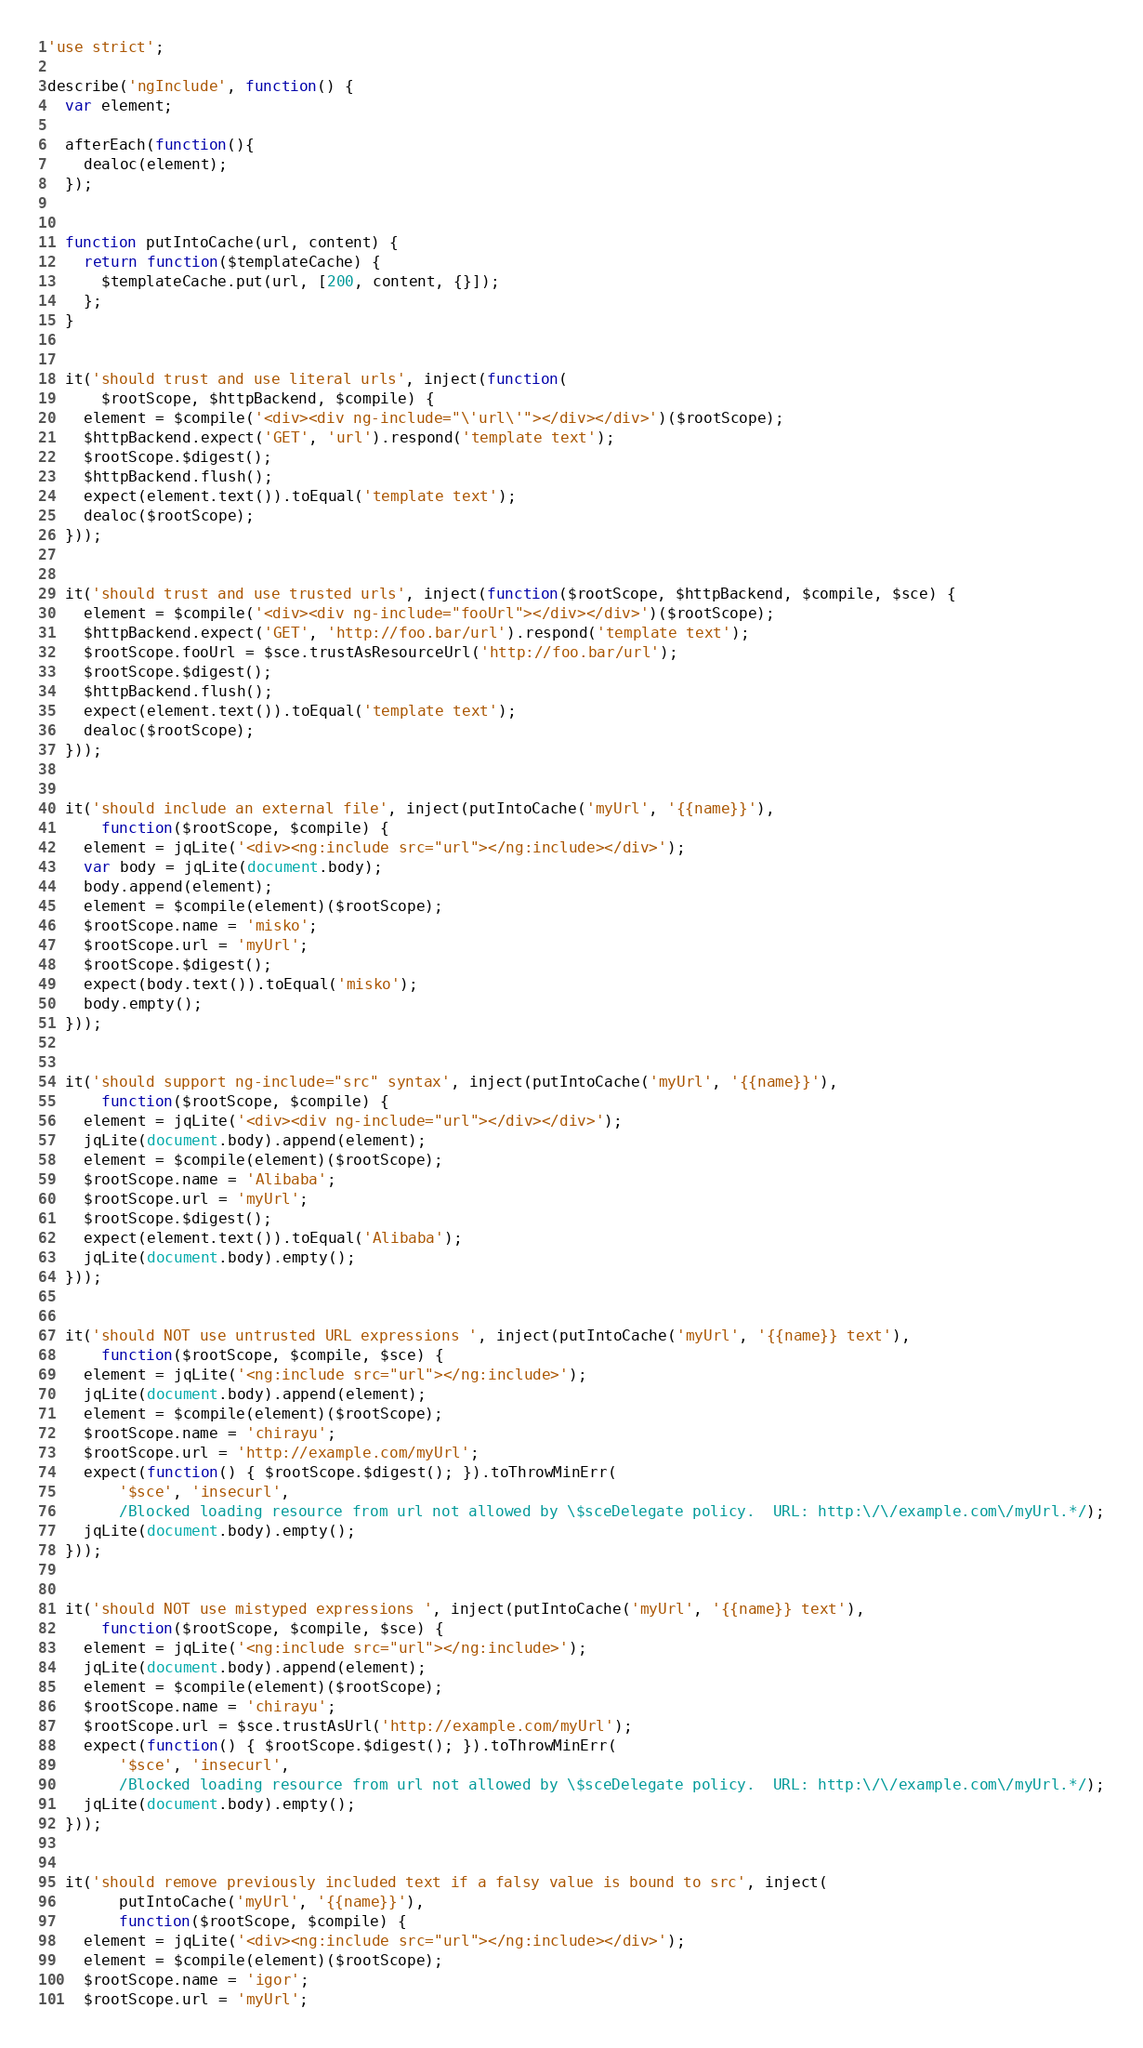Convert code to text. <code><loc_0><loc_0><loc_500><loc_500><_JavaScript_>'use strict';

describe('ngInclude', function() {
  var element;

  afterEach(function(){
    dealoc(element);
  });


  function putIntoCache(url, content) {
    return function($templateCache) {
      $templateCache.put(url, [200, content, {}]);
    };
  }


  it('should trust and use literal urls', inject(function(
      $rootScope, $httpBackend, $compile) {
    element = $compile('<div><div ng-include="\'url\'"></div></div>')($rootScope);
    $httpBackend.expect('GET', 'url').respond('template text');
    $rootScope.$digest();
    $httpBackend.flush();
    expect(element.text()).toEqual('template text');
    dealoc($rootScope);
  }));


  it('should trust and use trusted urls', inject(function($rootScope, $httpBackend, $compile, $sce) {
    element = $compile('<div><div ng-include="fooUrl"></div></div>')($rootScope);
    $httpBackend.expect('GET', 'http://foo.bar/url').respond('template text');
    $rootScope.fooUrl = $sce.trustAsResourceUrl('http://foo.bar/url');
    $rootScope.$digest();
    $httpBackend.flush();
    expect(element.text()).toEqual('template text');
    dealoc($rootScope);
  }));


  it('should include an external file', inject(putIntoCache('myUrl', '{{name}}'),
      function($rootScope, $compile) {
    element = jqLite('<div><ng:include src="url"></ng:include></div>');
    var body = jqLite(document.body);
    body.append(element);
    element = $compile(element)($rootScope);
    $rootScope.name = 'misko';
    $rootScope.url = 'myUrl';
    $rootScope.$digest();
    expect(body.text()).toEqual('misko');
    body.empty();
  }));


  it('should support ng-include="src" syntax', inject(putIntoCache('myUrl', '{{name}}'),
      function($rootScope, $compile) {
    element = jqLite('<div><div ng-include="url"></div></div>');
    jqLite(document.body).append(element);
    element = $compile(element)($rootScope);
    $rootScope.name = 'Alibaba';
    $rootScope.url = 'myUrl';
    $rootScope.$digest();
    expect(element.text()).toEqual('Alibaba');
    jqLite(document.body).empty();
  }));


  it('should NOT use untrusted URL expressions ', inject(putIntoCache('myUrl', '{{name}} text'),
      function($rootScope, $compile, $sce) {
    element = jqLite('<ng:include src="url"></ng:include>');
    jqLite(document.body).append(element);
    element = $compile(element)($rootScope);
    $rootScope.name = 'chirayu';
    $rootScope.url = 'http://example.com/myUrl';
    expect(function() { $rootScope.$digest(); }).toThrowMinErr(
        '$sce', 'insecurl',
        /Blocked loading resource from url not allowed by \$sceDelegate policy.  URL: http:\/\/example.com\/myUrl.*/);
    jqLite(document.body).empty();
  }));


  it('should NOT use mistyped expressions ', inject(putIntoCache('myUrl', '{{name}} text'),
      function($rootScope, $compile, $sce) {
    element = jqLite('<ng:include src="url"></ng:include>');
    jqLite(document.body).append(element);
    element = $compile(element)($rootScope);
    $rootScope.name = 'chirayu';
    $rootScope.url = $sce.trustAsUrl('http://example.com/myUrl');
    expect(function() { $rootScope.$digest(); }).toThrowMinErr(
        '$sce', 'insecurl',
        /Blocked loading resource from url not allowed by \$sceDelegate policy.  URL: http:\/\/example.com\/myUrl.*/);
    jqLite(document.body).empty();
  }));


  it('should remove previously included text if a falsy value is bound to src', inject(
        putIntoCache('myUrl', '{{name}}'),
        function($rootScope, $compile) {
    element = jqLite('<div><ng:include src="url"></ng:include></div>');
    element = $compile(element)($rootScope);
    $rootScope.name = 'igor';
    $rootScope.url = 'myUrl';</code> 